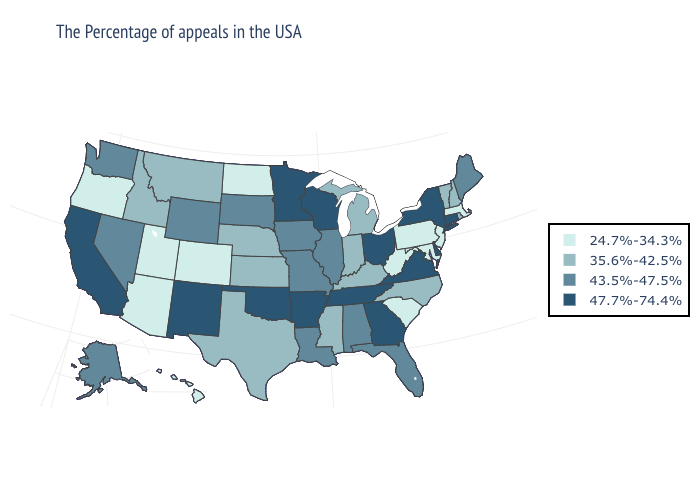Does Virginia have the highest value in the South?
Answer briefly. Yes. Does Oklahoma have the lowest value in the USA?
Answer briefly. No. What is the highest value in the West ?
Concise answer only. 47.7%-74.4%. Which states hav the highest value in the Northeast?
Keep it brief. Connecticut, New York. Among the states that border Maine , which have the lowest value?
Give a very brief answer. New Hampshire. What is the value of Washington?
Be succinct. 43.5%-47.5%. Name the states that have a value in the range 43.5%-47.5%?
Concise answer only. Maine, Florida, Alabama, Illinois, Louisiana, Missouri, Iowa, South Dakota, Wyoming, Nevada, Washington, Alaska. Is the legend a continuous bar?
Concise answer only. No. What is the value of North Dakota?
Quick response, please. 24.7%-34.3%. What is the lowest value in the USA?
Answer briefly. 24.7%-34.3%. What is the highest value in the West ?
Write a very short answer. 47.7%-74.4%. What is the highest value in the South ?
Keep it brief. 47.7%-74.4%. Does the first symbol in the legend represent the smallest category?
Answer briefly. Yes. Does the first symbol in the legend represent the smallest category?
Give a very brief answer. Yes. Name the states that have a value in the range 43.5%-47.5%?
Quick response, please. Maine, Florida, Alabama, Illinois, Louisiana, Missouri, Iowa, South Dakota, Wyoming, Nevada, Washington, Alaska. 